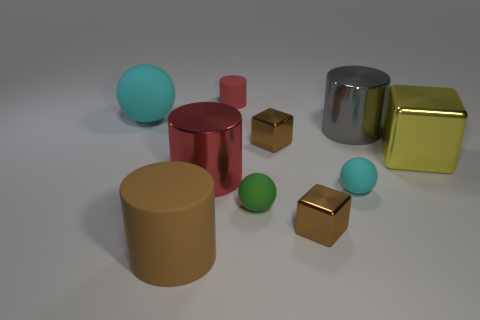What is the material of the object that is the same color as the small rubber cylinder?
Provide a short and direct response. Metal. What color is the large rubber thing that is the same shape as the large gray metallic thing?
Your answer should be compact. Brown. Is there anything else that has the same shape as the green thing?
Keep it short and to the point. Yes. Is the size of the red metallic cylinder the same as the cylinder that is to the right of the tiny cyan matte thing?
Your answer should be very brief. Yes. Is the number of big purple objects greater than the number of gray shiny objects?
Offer a terse response. No. Is the ball on the left side of the brown matte thing made of the same material as the cyan sphere that is on the right side of the big rubber cylinder?
Offer a very short reply. Yes. What is the small red thing made of?
Your response must be concise. Rubber. Is the number of red things that are behind the green thing greater than the number of tiny brown blocks?
Provide a succinct answer. No. There is a cyan object on the right side of the big cylinder that is in front of the green matte thing; how many cyan matte objects are behind it?
Provide a short and direct response. 1. There is a thing that is both right of the large red object and left of the tiny green matte object; what is its material?
Offer a very short reply. Rubber. 